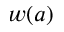<formula> <loc_0><loc_0><loc_500><loc_500>w ( a )</formula> 